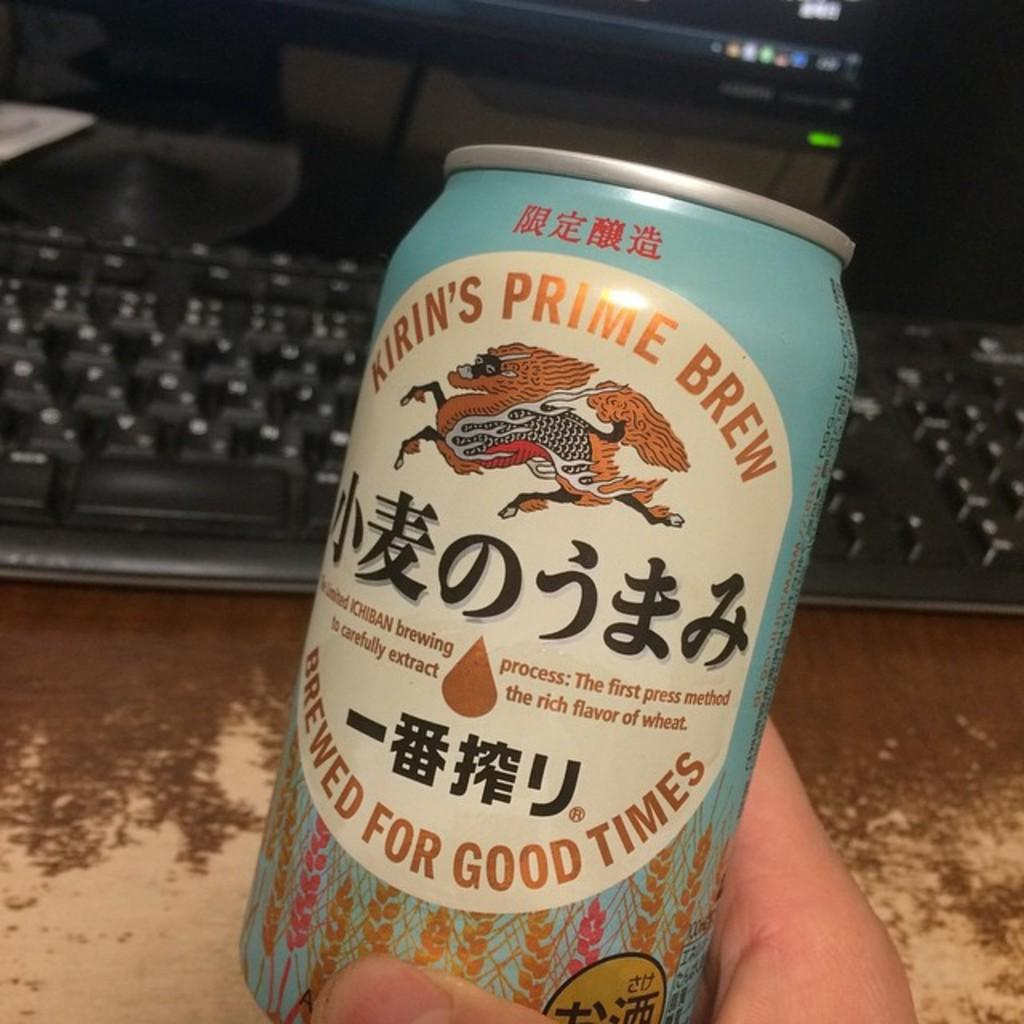<image>
Relay a brief, clear account of the picture shown. A person is holding a can of Kirin's Prime Brew. 